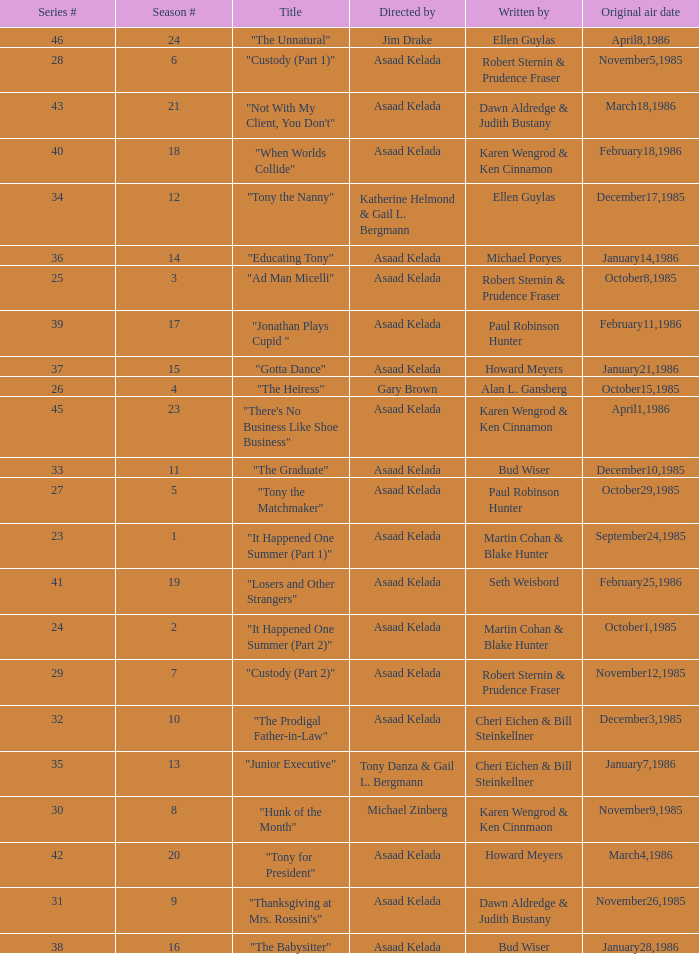Who were the authors of series episode #25? Robert Sternin & Prudence Fraser. 